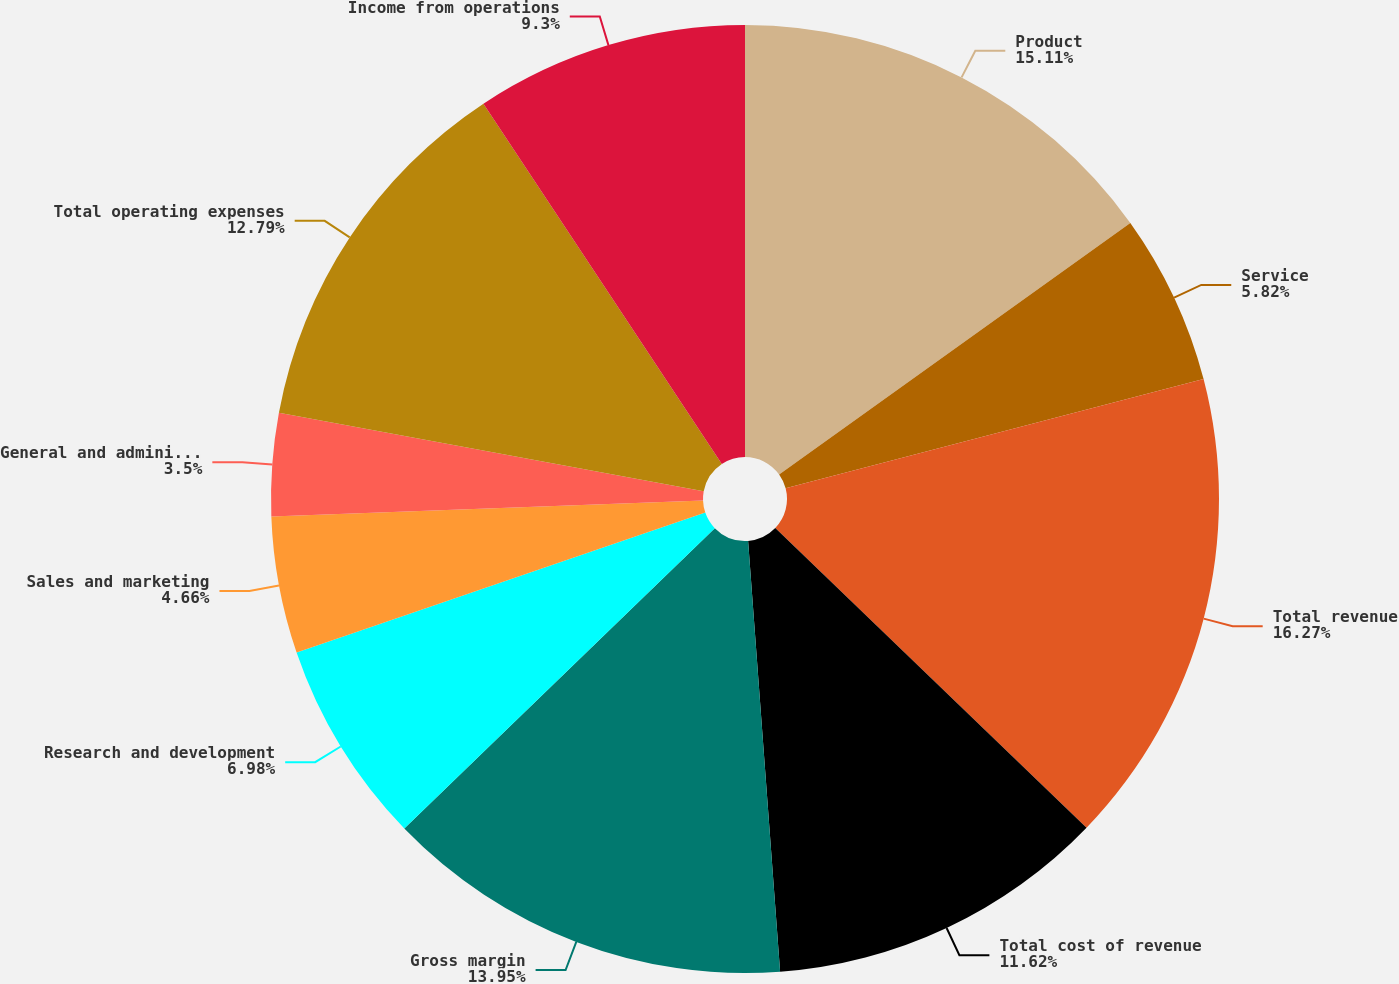<chart> <loc_0><loc_0><loc_500><loc_500><pie_chart><fcel>Product<fcel>Service<fcel>Total revenue<fcel>Total cost of revenue<fcel>Gross margin<fcel>Research and development<fcel>Sales and marketing<fcel>General and administrative<fcel>Total operating expenses<fcel>Income from operations<nl><fcel>15.1%<fcel>5.82%<fcel>16.26%<fcel>11.62%<fcel>13.94%<fcel>6.98%<fcel>4.66%<fcel>3.5%<fcel>12.78%<fcel>9.3%<nl></chart> 